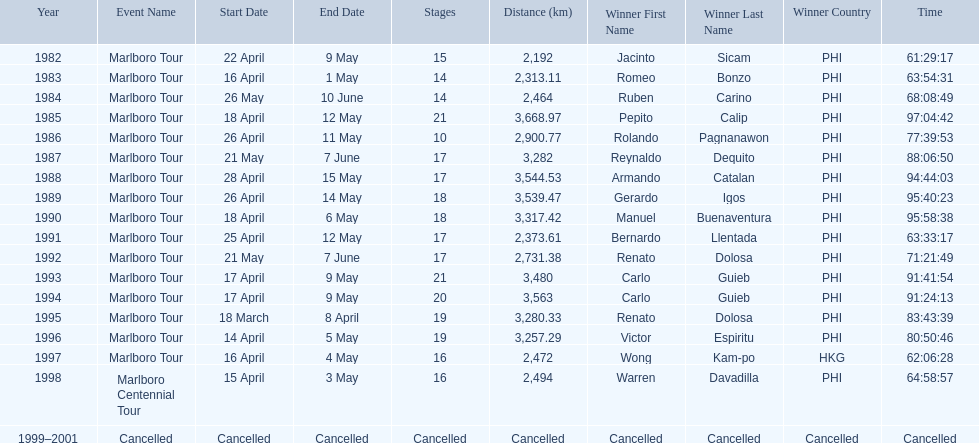How far did the marlboro tour travel each year? 2,192 km, 2,313.11 km, 2,464 km, 3,668.97 km, 2,900.77 km, 3,282 km, 3,544.53 km, 3,539.47 km, 3,317.42 km, 2,373.61 km, 2,731.38 km, 3,480 km, 3,563 km, 3,280.33 km, 3,257.29 km, 2,472 km, 2,494 km, Cancelled. In what year did they travel the furthest? 1985. How far did they travel that year? 3,668.97 km. 